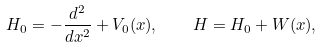<formula> <loc_0><loc_0><loc_500><loc_500>H _ { 0 } = - \frac { d ^ { 2 } } { d x ^ { 2 } } + V _ { 0 } ( x ) , \quad H = H _ { 0 } + W ( x ) ,</formula> 